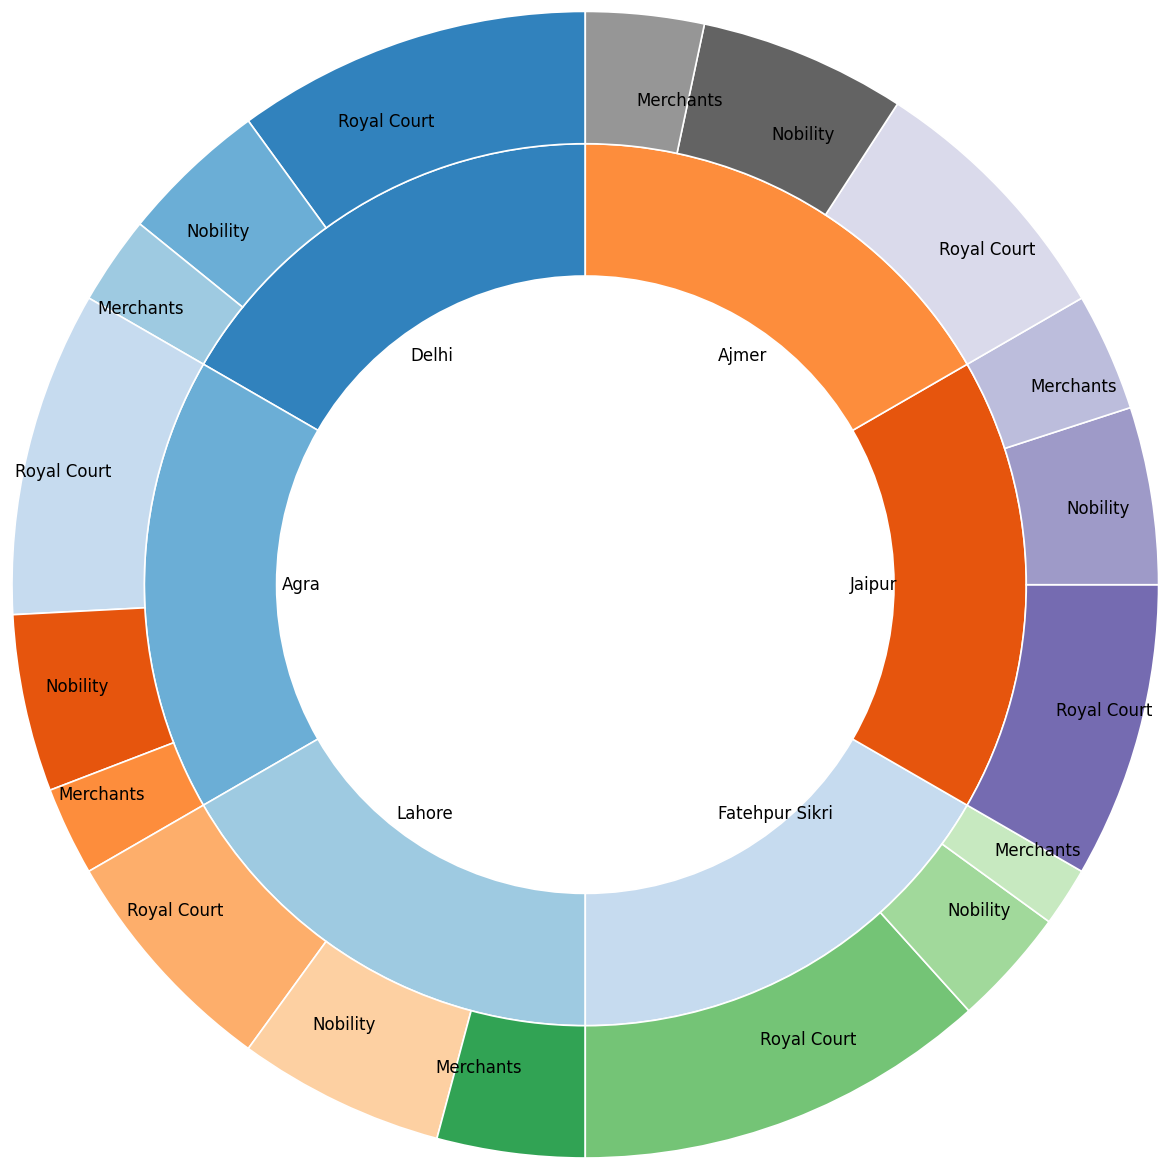What percentage of art patronage in Delhi is attributed to the Nobility? The segment showing 'Nobility' in the part of the pie chart corresponding to Delhi is labeled with a percentage value.
Answer: 25% Which is the city with the highest percentage of Royal Court patronage? By observing the segments labeled 'Royal Court' for each city, the largest segment is associated with Fatehpur Sikri.
Answer: Fatehpur Sikri How does the merchant patronage in Lahore compare with that in Agra? Compare the segments labeled 'Merchants' for Lahore and Agra; Lahore's is 25%, while Agra's is 15%. Therefore, Lahore's Merchant patronage is greater.
Answer: Lahore has greater merchant patronage What is the total percentage of patronage from the Nobility across all cities? Sum the percentages for the Nobility in each city: 25% (Delhi) + 30% (Agra) + 35% (Lahore) + 20% (Fatehpur Sikri) + 30% (Jaipur) + 35% (Ajmer) = 175%.
Answer: 175% Which city has the smallest contribution from merchants? By comparing the segments labeled 'Merchants' for all cities, the smallest segment belongs to Fatehpur Sikri with 10%.
Answer: Fatehpur Sikri How does the Royal Court patronage in Ajmer compare to that in Lahore? Compare the segments labeled 'Royal Court' for Ajmer and Lahore; Ajmer's is 45% and Lahore's is 40%. Therefore, Ajmer's Royal Court patronage is slightly higher.
Answer: Ajmer has higher Royal Court patronage What is the average percentage of all types of patronages in Agra? Compute the average: (55% + 30% + 15%) / 3 = 33.33%.
Answer: 33.33% If we combine the patronage of merchants in Delhi, Agra, and Jaipur, what would be their total percentage? Sum the percentage values for the merchants in these three cities: 15% (Delhi) + 15% (Agra) + 20% (Jaipur) = 50%.
Answer: 50% Which city has the balanced patronage distribution among Royal Court, Nobility, and Merchants? By observing the segments, Delhi (60%, 25%, 15%) and Lahore (40%, 35%, 25%) both have relatively balanced distributions, but Delhi’s values show a greater skew towards Royal Court compared to Lahore.
Answer: Lahore What is the percentage difference in Nobility patronage between Jaipur and Fatehpur Sikri? Calculate the difference: 30% (Jaipur) - 20% (Fatehpur Sikri) = 10%.
Answer: 10% 